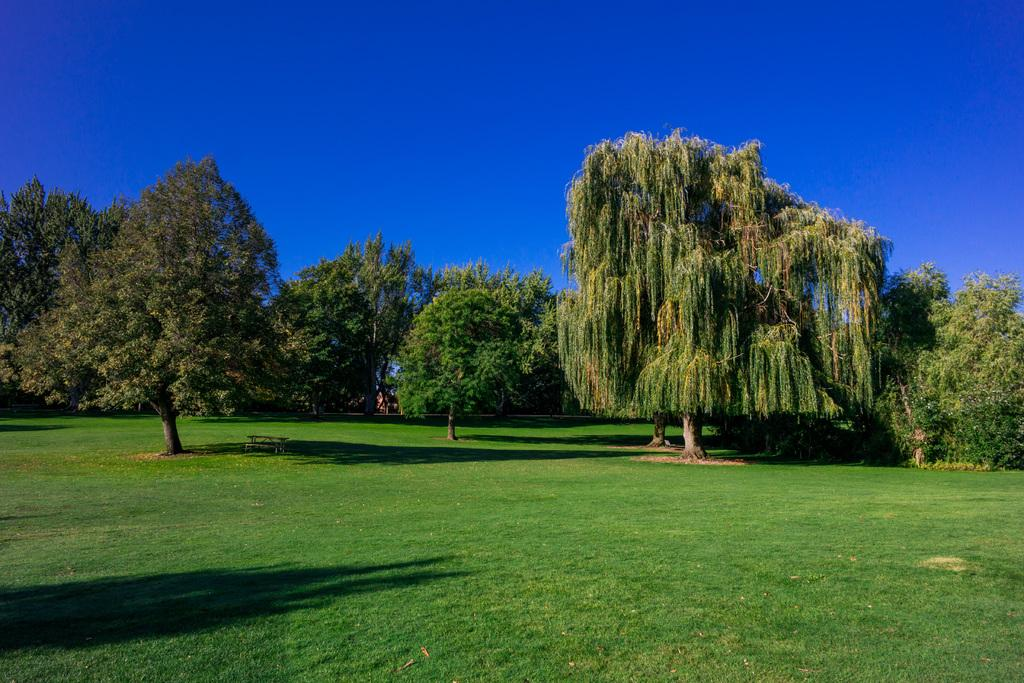What type of seating is visible in the image? There is a bench in the image. What type of vegetation is present in the image? There is grass in the image. What other natural elements can be seen in the image? There are trees in the image. What is visible in the background of the image? The sky is visible in the background of the image. What type of mitten is being used by the committee in the image? There is no mitten or committee present in the image. What phase of the moon is visible in the image? The image does not show the moon; it only shows the sky in the background. 